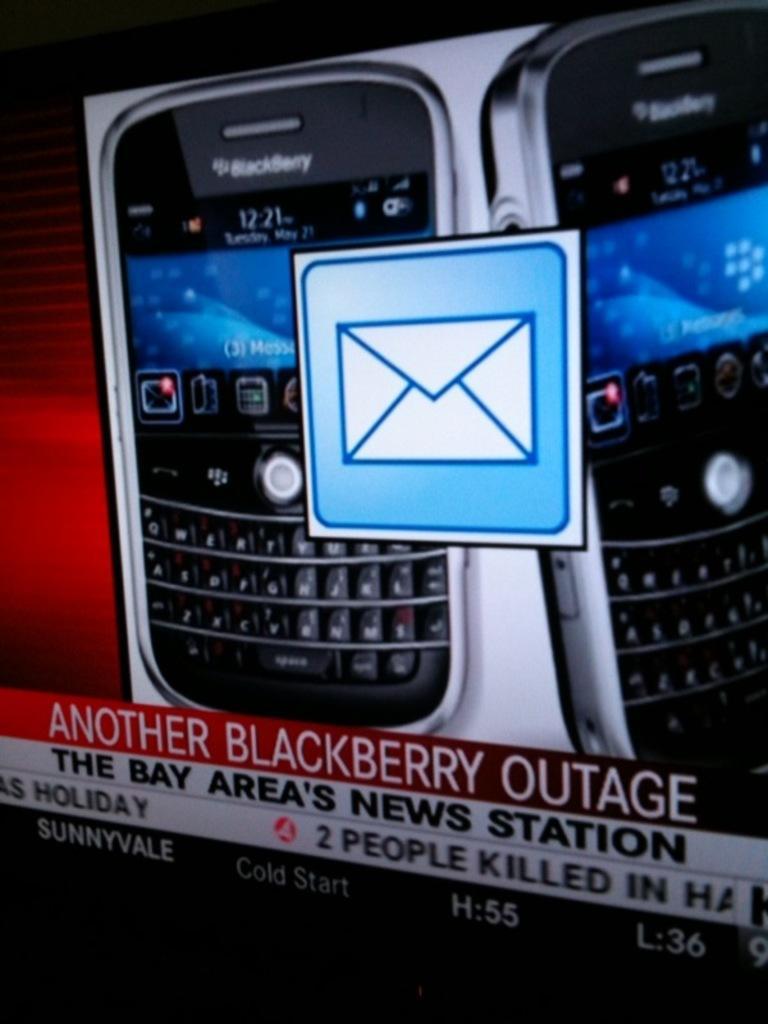How would you summarize this image in a sentence or two? In this image, we can see two black berry mobile phones on a picture and there is ANOTHER BLACKBERRY OUTAGE printed in red color. 